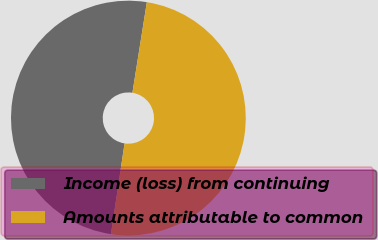Convert chart to OTSL. <chart><loc_0><loc_0><loc_500><loc_500><pie_chart><fcel>Income (loss) from continuing<fcel>Amounts attributable to common<nl><fcel>50.14%<fcel>49.86%<nl></chart> 